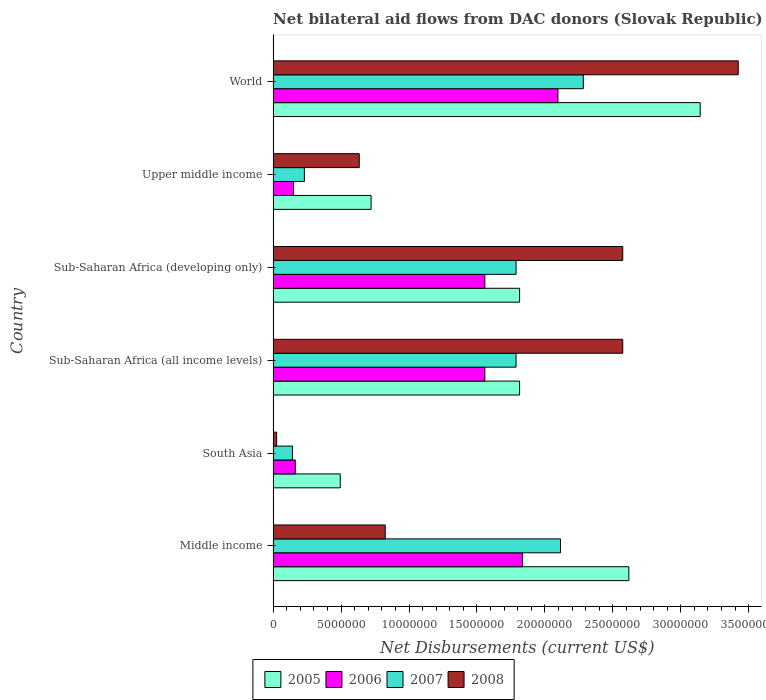How many different coloured bars are there?
Provide a succinct answer. 4. How many groups of bars are there?
Ensure brevity in your answer.  6. Are the number of bars per tick equal to the number of legend labels?
Your response must be concise. Yes. How many bars are there on the 5th tick from the top?
Offer a terse response. 4. How many bars are there on the 3rd tick from the bottom?
Keep it short and to the point. 4. What is the label of the 4th group of bars from the top?
Your answer should be compact. Sub-Saharan Africa (all income levels). In how many cases, is the number of bars for a given country not equal to the number of legend labels?
Offer a terse response. 0. What is the net bilateral aid flows in 2005 in World?
Ensure brevity in your answer.  3.14e+07. Across all countries, what is the maximum net bilateral aid flows in 2007?
Make the answer very short. 2.28e+07. Across all countries, what is the minimum net bilateral aid flows in 2008?
Offer a terse response. 2.60e+05. In which country was the net bilateral aid flows in 2006 minimum?
Provide a succinct answer. Upper middle income. What is the total net bilateral aid flows in 2007 in the graph?
Your response must be concise. 8.35e+07. What is the difference between the net bilateral aid flows in 2005 in Middle income and that in Sub-Saharan Africa (all income levels)?
Provide a succinct answer. 8.04e+06. What is the average net bilateral aid flows in 2008 per country?
Your response must be concise. 1.68e+07. What is the difference between the net bilateral aid flows in 2005 and net bilateral aid flows in 2008 in Sub-Saharan Africa (all income levels)?
Offer a very short reply. -7.59e+06. What is the ratio of the net bilateral aid flows in 2008 in South Asia to that in Sub-Saharan Africa (all income levels)?
Make the answer very short. 0.01. Is the net bilateral aid flows in 2007 in Middle income less than that in Upper middle income?
Your answer should be compact. No. Is the difference between the net bilateral aid flows in 2005 in Sub-Saharan Africa (developing only) and World greater than the difference between the net bilateral aid flows in 2008 in Sub-Saharan Africa (developing only) and World?
Your answer should be very brief. No. What is the difference between the highest and the second highest net bilateral aid flows in 2005?
Provide a succinct answer. 5.25e+06. What is the difference between the highest and the lowest net bilateral aid flows in 2007?
Provide a short and direct response. 2.14e+07. In how many countries, is the net bilateral aid flows in 2005 greater than the average net bilateral aid flows in 2005 taken over all countries?
Keep it short and to the point. 4. Is the sum of the net bilateral aid flows in 2007 in Upper middle income and World greater than the maximum net bilateral aid flows in 2005 across all countries?
Your answer should be very brief. No. What does the 4th bar from the bottom in Upper middle income represents?
Provide a succinct answer. 2008. Is it the case that in every country, the sum of the net bilateral aid flows in 2006 and net bilateral aid flows in 2005 is greater than the net bilateral aid flows in 2008?
Provide a short and direct response. Yes. Are all the bars in the graph horizontal?
Offer a terse response. Yes. What is the difference between two consecutive major ticks on the X-axis?
Your answer should be compact. 5.00e+06. Where does the legend appear in the graph?
Provide a succinct answer. Bottom center. How many legend labels are there?
Provide a short and direct response. 4. How are the legend labels stacked?
Offer a very short reply. Horizontal. What is the title of the graph?
Offer a very short reply. Net bilateral aid flows from DAC donors (Slovak Republic). Does "1991" appear as one of the legend labels in the graph?
Make the answer very short. No. What is the label or title of the X-axis?
Offer a terse response. Net Disbursements (current US$). What is the Net Disbursements (current US$) of 2005 in Middle income?
Give a very brief answer. 2.62e+07. What is the Net Disbursements (current US$) in 2006 in Middle income?
Provide a short and direct response. 1.84e+07. What is the Net Disbursements (current US$) in 2007 in Middle income?
Ensure brevity in your answer.  2.12e+07. What is the Net Disbursements (current US$) of 2008 in Middle income?
Make the answer very short. 8.25e+06. What is the Net Disbursements (current US$) in 2005 in South Asia?
Provide a succinct answer. 4.94e+06. What is the Net Disbursements (current US$) in 2006 in South Asia?
Your answer should be compact. 1.63e+06. What is the Net Disbursements (current US$) in 2007 in South Asia?
Provide a short and direct response. 1.42e+06. What is the Net Disbursements (current US$) in 2005 in Sub-Saharan Africa (all income levels)?
Your answer should be compact. 1.81e+07. What is the Net Disbursements (current US$) in 2006 in Sub-Saharan Africa (all income levels)?
Provide a succinct answer. 1.56e+07. What is the Net Disbursements (current US$) of 2007 in Sub-Saharan Africa (all income levels)?
Ensure brevity in your answer.  1.79e+07. What is the Net Disbursements (current US$) of 2008 in Sub-Saharan Africa (all income levels)?
Provide a short and direct response. 2.57e+07. What is the Net Disbursements (current US$) of 2005 in Sub-Saharan Africa (developing only)?
Your answer should be compact. 1.81e+07. What is the Net Disbursements (current US$) of 2006 in Sub-Saharan Africa (developing only)?
Offer a terse response. 1.56e+07. What is the Net Disbursements (current US$) of 2007 in Sub-Saharan Africa (developing only)?
Make the answer very short. 1.79e+07. What is the Net Disbursements (current US$) in 2008 in Sub-Saharan Africa (developing only)?
Keep it short and to the point. 2.57e+07. What is the Net Disbursements (current US$) of 2005 in Upper middle income?
Give a very brief answer. 7.21e+06. What is the Net Disbursements (current US$) in 2006 in Upper middle income?
Offer a terse response. 1.50e+06. What is the Net Disbursements (current US$) of 2007 in Upper middle income?
Your answer should be very brief. 2.30e+06. What is the Net Disbursements (current US$) in 2008 in Upper middle income?
Your answer should be very brief. 6.34e+06. What is the Net Disbursements (current US$) of 2005 in World?
Your answer should be compact. 3.14e+07. What is the Net Disbursements (current US$) in 2006 in World?
Make the answer very short. 2.10e+07. What is the Net Disbursements (current US$) of 2007 in World?
Your response must be concise. 2.28e+07. What is the Net Disbursements (current US$) in 2008 in World?
Provide a short and direct response. 3.42e+07. Across all countries, what is the maximum Net Disbursements (current US$) of 2005?
Your response must be concise. 3.14e+07. Across all countries, what is the maximum Net Disbursements (current US$) in 2006?
Offer a very short reply. 2.10e+07. Across all countries, what is the maximum Net Disbursements (current US$) of 2007?
Keep it short and to the point. 2.28e+07. Across all countries, what is the maximum Net Disbursements (current US$) in 2008?
Provide a succinct answer. 3.42e+07. Across all countries, what is the minimum Net Disbursements (current US$) of 2005?
Give a very brief answer. 4.94e+06. Across all countries, what is the minimum Net Disbursements (current US$) in 2006?
Your answer should be very brief. 1.50e+06. Across all countries, what is the minimum Net Disbursements (current US$) in 2007?
Your answer should be very brief. 1.42e+06. Across all countries, what is the minimum Net Disbursements (current US$) of 2008?
Make the answer very short. 2.60e+05. What is the total Net Disbursements (current US$) of 2005 in the graph?
Make the answer very short. 1.06e+08. What is the total Net Disbursements (current US$) of 2006 in the graph?
Make the answer very short. 7.36e+07. What is the total Net Disbursements (current US$) in 2007 in the graph?
Offer a very short reply. 8.35e+07. What is the total Net Disbursements (current US$) in 2008 in the graph?
Your answer should be very brief. 1.01e+08. What is the difference between the Net Disbursements (current US$) in 2005 in Middle income and that in South Asia?
Give a very brief answer. 2.12e+07. What is the difference between the Net Disbursements (current US$) in 2006 in Middle income and that in South Asia?
Offer a very short reply. 1.67e+07. What is the difference between the Net Disbursements (current US$) of 2007 in Middle income and that in South Asia?
Keep it short and to the point. 1.97e+07. What is the difference between the Net Disbursements (current US$) in 2008 in Middle income and that in South Asia?
Offer a very short reply. 7.99e+06. What is the difference between the Net Disbursements (current US$) in 2005 in Middle income and that in Sub-Saharan Africa (all income levels)?
Provide a short and direct response. 8.04e+06. What is the difference between the Net Disbursements (current US$) in 2006 in Middle income and that in Sub-Saharan Africa (all income levels)?
Provide a succinct answer. 2.77e+06. What is the difference between the Net Disbursements (current US$) of 2007 in Middle income and that in Sub-Saharan Africa (all income levels)?
Provide a succinct answer. 3.27e+06. What is the difference between the Net Disbursements (current US$) in 2008 in Middle income and that in Sub-Saharan Africa (all income levels)?
Give a very brief answer. -1.75e+07. What is the difference between the Net Disbursements (current US$) in 2005 in Middle income and that in Sub-Saharan Africa (developing only)?
Make the answer very short. 8.04e+06. What is the difference between the Net Disbursements (current US$) of 2006 in Middle income and that in Sub-Saharan Africa (developing only)?
Give a very brief answer. 2.77e+06. What is the difference between the Net Disbursements (current US$) in 2007 in Middle income and that in Sub-Saharan Africa (developing only)?
Your answer should be very brief. 3.27e+06. What is the difference between the Net Disbursements (current US$) of 2008 in Middle income and that in Sub-Saharan Africa (developing only)?
Provide a short and direct response. -1.75e+07. What is the difference between the Net Disbursements (current US$) in 2005 in Middle income and that in Upper middle income?
Make the answer very short. 1.90e+07. What is the difference between the Net Disbursements (current US$) in 2006 in Middle income and that in Upper middle income?
Offer a terse response. 1.68e+07. What is the difference between the Net Disbursements (current US$) in 2007 in Middle income and that in Upper middle income?
Offer a very short reply. 1.88e+07. What is the difference between the Net Disbursements (current US$) in 2008 in Middle income and that in Upper middle income?
Provide a succinct answer. 1.91e+06. What is the difference between the Net Disbursements (current US$) in 2005 in Middle income and that in World?
Give a very brief answer. -5.25e+06. What is the difference between the Net Disbursements (current US$) in 2006 in Middle income and that in World?
Offer a terse response. -2.61e+06. What is the difference between the Net Disbursements (current US$) of 2007 in Middle income and that in World?
Your response must be concise. -1.68e+06. What is the difference between the Net Disbursements (current US$) in 2008 in Middle income and that in World?
Your answer should be very brief. -2.60e+07. What is the difference between the Net Disbursements (current US$) in 2005 in South Asia and that in Sub-Saharan Africa (all income levels)?
Your answer should be compact. -1.32e+07. What is the difference between the Net Disbursements (current US$) of 2006 in South Asia and that in Sub-Saharan Africa (all income levels)?
Your response must be concise. -1.40e+07. What is the difference between the Net Disbursements (current US$) of 2007 in South Asia and that in Sub-Saharan Africa (all income levels)?
Your answer should be compact. -1.65e+07. What is the difference between the Net Disbursements (current US$) in 2008 in South Asia and that in Sub-Saharan Africa (all income levels)?
Your response must be concise. -2.55e+07. What is the difference between the Net Disbursements (current US$) in 2005 in South Asia and that in Sub-Saharan Africa (developing only)?
Your response must be concise. -1.32e+07. What is the difference between the Net Disbursements (current US$) in 2006 in South Asia and that in Sub-Saharan Africa (developing only)?
Your answer should be compact. -1.40e+07. What is the difference between the Net Disbursements (current US$) in 2007 in South Asia and that in Sub-Saharan Africa (developing only)?
Ensure brevity in your answer.  -1.65e+07. What is the difference between the Net Disbursements (current US$) of 2008 in South Asia and that in Sub-Saharan Africa (developing only)?
Your answer should be very brief. -2.55e+07. What is the difference between the Net Disbursements (current US$) of 2005 in South Asia and that in Upper middle income?
Give a very brief answer. -2.27e+06. What is the difference between the Net Disbursements (current US$) in 2006 in South Asia and that in Upper middle income?
Offer a terse response. 1.30e+05. What is the difference between the Net Disbursements (current US$) in 2007 in South Asia and that in Upper middle income?
Offer a terse response. -8.80e+05. What is the difference between the Net Disbursements (current US$) of 2008 in South Asia and that in Upper middle income?
Your answer should be compact. -6.08e+06. What is the difference between the Net Disbursements (current US$) of 2005 in South Asia and that in World?
Offer a very short reply. -2.65e+07. What is the difference between the Net Disbursements (current US$) in 2006 in South Asia and that in World?
Give a very brief answer. -1.93e+07. What is the difference between the Net Disbursements (current US$) of 2007 in South Asia and that in World?
Your answer should be very brief. -2.14e+07. What is the difference between the Net Disbursements (current US$) in 2008 in South Asia and that in World?
Provide a short and direct response. -3.40e+07. What is the difference between the Net Disbursements (current US$) of 2006 in Sub-Saharan Africa (all income levels) and that in Sub-Saharan Africa (developing only)?
Your answer should be very brief. 0. What is the difference between the Net Disbursements (current US$) in 2007 in Sub-Saharan Africa (all income levels) and that in Sub-Saharan Africa (developing only)?
Provide a short and direct response. 0. What is the difference between the Net Disbursements (current US$) in 2005 in Sub-Saharan Africa (all income levels) and that in Upper middle income?
Make the answer very short. 1.09e+07. What is the difference between the Net Disbursements (current US$) of 2006 in Sub-Saharan Africa (all income levels) and that in Upper middle income?
Your response must be concise. 1.41e+07. What is the difference between the Net Disbursements (current US$) in 2007 in Sub-Saharan Africa (all income levels) and that in Upper middle income?
Your response must be concise. 1.56e+07. What is the difference between the Net Disbursements (current US$) in 2008 in Sub-Saharan Africa (all income levels) and that in Upper middle income?
Ensure brevity in your answer.  1.94e+07. What is the difference between the Net Disbursements (current US$) of 2005 in Sub-Saharan Africa (all income levels) and that in World?
Your answer should be compact. -1.33e+07. What is the difference between the Net Disbursements (current US$) in 2006 in Sub-Saharan Africa (all income levels) and that in World?
Offer a terse response. -5.38e+06. What is the difference between the Net Disbursements (current US$) of 2007 in Sub-Saharan Africa (all income levels) and that in World?
Make the answer very short. -4.95e+06. What is the difference between the Net Disbursements (current US$) in 2008 in Sub-Saharan Africa (all income levels) and that in World?
Offer a terse response. -8.50e+06. What is the difference between the Net Disbursements (current US$) of 2005 in Sub-Saharan Africa (developing only) and that in Upper middle income?
Your answer should be very brief. 1.09e+07. What is the difference between the Net Disbursements (current US$) in 2006 in Sub-Saharan Africa (developing only) and that in Upper middle income?
Make the answer very short. 1.41e+07. What is the difference between the Net Disbursements (current US$) of 2007 in Sub-Saharan Africa (developing only) and that in Upper middle income?
Give a very brief answer. 1.56e+07. What is the difference between the Net Disbursements (current US$) in 2008 in Sub-Saharan Africa (developing only) and that in Upper middle income?
Keep it short and to the point. 1.94e+07. What is the difference between the Net Disbursements (current US$) of 2005 in Sub-Saharan Africa (developing only) and that in World?
Your response must be concise. -1.33e+07. What is the difference between the Net Disbursements (current US$) of 2006 in Sub-Saharan Africa (developing only) and that in World?
Provide a succinct answer. -5.38e+06. What is the difference between the Net Disbursements (current US$) of 2007 in Sub-Saharan Africa (developing only) and that in World?
Keep it short and to the point. -4.95e+06. What is the difference between the Net Disbursements (current US$) of 2008 in Sub-Saharan Africa (developing only) and that in World?
Offer a very short reply. -8.50e+06. What is the difference between the Net Disbursements (current US$) in 2005 in Upper middle income and that in World?
Make the answer very short. -2.42e+07. What is the difference between the Net Disbursements (current US$) of 2006 in Upper middle income and that in World?
Your answer should be very brief. -1.95e+07. What is the difference between the Net Disbursements (current US$) in 2007 in Upper middle income and that in World?
Ensure brevity in your answer.  -2.05e+07. What is the difference between the Net Disbursements (current US$) of 2008 in Upper middle income and that in World?
Keep it short and to the point. -2.79e+07. What is the difference between the Net Disbursements (current US$) of 2005 in Middle income and the Net Disbursements (current US$) of 2006 in South Asia?
Provide a short and direct response. 2.46e+07. What is the difference between the Net Disbursements (current US$) in 2005 in Middle income and the Net Disbursements (current US$) in 2007 in South Asia?
Ensure brevity in your answer.  2.48e+07. What is the difference between the Net Disbursements (current US$) in 2005 in Middle income and the Net Disbursements (current US$) in 2008 in South Asia?
Make the answer very short. 2.59e+07. What is the difference between the Net Disbursements (current US$) of 2006 in Middle income and the Net Disbursements (current US$) of 2007 in South Asia?
Offer a very short reply. 1.69e+07. What is the difference between the Net Disbursements (current US$) in 2006 in Middle income and the Net Disbursements (current US$) in 2008 in South Asia?
Your answer should be compact. 1.81e+07. What is the difference between the Net Disbursements (current US$) in 2007 in Middle income and the Net Disbursements (current US$) in 2008 in South Asia?
Offer a very short reply. 2.09e+07. What is the difference between the Net Disbursements (current US$) in 2005 in Middle income and the Net Disbursements (current US$) in 2006 in Sub-Saharan Africa (all income levels)?
Provide a short and direct response. 1.06e+07. What is the difference between the Net Disbursements (current US$) in 2005 in Middle income and the Net Disbursements (current US$) in 2007 in Sub-Saharan Africa (all income levels)?
Keep it short and to the point. 8.30e+06. What is the difference between the Net Disbursements (current US$) in 2006 in Middle income and the Net Disbursements (current US$) in 2008 in Sub-Saharan Africa (all income levels)?
Your answer should be compact. -7.38e+06. What is the difference between the Net Disbursements (current US$) in 2007 in Middle income and the Net Disbursements (current US$) in 2008 in Sub-Saharan Africa (all income levels)?
Ensure brevity in your answer.  -4.58e+06. What is the difference between the Net Disbursements (current US$) in 2005 in Middle income and the Net Disbursements (current US$) in 2006 in Sub-Saharan Africa (developing only)?
Provide a succinct answer. 1.06e+07. What is the difference between the Net Disbursements (current US$) in 2005 in Middle income and the Net Disbursements (current US$) in 2007 in Sub-Saharan Africa (developing only)?
Provide a short and direct response. 8.30e+06. What is the difference between the Net Disbursements (current US$) in 2005 in Middle income and the Net Disbursements (current US$) in 2008 in Sub-Saharan Africa (developing only)?
Offer a terse response. 4.50e+05. What is the difference between the Net Disbursements (current US$) in 2006 in Middle income and the Net Disbursements (current US$) in 2008 in Sub-Saharan Africa (developing only)?
Keep it short and to the point. -7.38e+06. What is the difference between the Net Disbursements (current US$) of 2007 in Middle income and the Net Disbursements (current US$) of 2008 in Sub-Saharan Africa (developing only)?
Offer a very short reply. -4.58e+06. What is the difference between the Net Disbursements (current US$) in 2005 in Middle income and the Net Disbursements (current US$) in 2006 in Upper middle income?
Ensure brevity in your answer.  2.47e+07. What is the difference between the Net Disbursements (current US$) of 2005 in Middle income and the Net Disbursements (current US$) of 2007 in Upper middle income?
Your answer should be compact. 2.39e+07. What is the difference between the Net Disbursements (current US$) of 2005 in Middle income and the Net Disbursements (current US$) of 2008 in Upper middle income?
Offer a terse response. 1.98e+07. What is the difference between the Net Disbursements (current US$) of 2006 in Middle income and the Net Disbursements (current US$) of 2007 in Upper middle income?
Make the answer very short. 1.60e+07. What is the difference between the Net Disbursements (current US$) of 2006 in Middle income and the Net Disbursements (current US$) of 2008 in Upper middle income?
Keep it short and to the point. 1.20e+07. What is the difference between the Net Disbursements (current US$) in 2007 in Middle income and the Net Disbursements (current US$) in 2008 in Upper middle income?
Keep it short and to the point. 1.48e+07. What is the difference between the Net Disbursements (current US$) in 2005 in Middle income and the Net Disbursements (current US$) in 2006 in World?
Your answer should be very brief. 5.22e+06. What is the difference between the Net Disbursements (current US$) in 2005 in Middle income and the Net Disbursements (current US$) in 2007 in World?
Provide a short and direct response. 3.35e+06. What is the difference between the Net Disbursements (current US$) in 2005 in Middle income and the Net Disbursements (current US$) in 2008 in World?
Make the answer very short. -8.05e+06. What is the difference between the Net Disbursements (current US$) in 2006 in Middle income and the Net Disbursements (current US$) in 2007 in World?
Offer a very short reply. -4.48e+06. What is the difference between the Net Disbursements (current US$) of 2006 in Middle income and the Net Disbursements (current US$) of 2008 in World?
Your response must be concise. -1.59e+07. What is the difference between the Net Disbursements (current US$) in 2007 in Middle income and the Net Disbursements (current US$) in 2008 in World?
Give a very brief answer. -1.31e+07. What is the difference between the Net Disbursements (current US$) in 2005 in South Asia and the Net Disbursements (current US$) in 2006 in Sub-Saharan Africa (all income levels)?
Your answer should be compact. -1.06e+07. What is the difference between the Net Disbursements (current US$) in 2005 in South Asia and the Net Disbursements (current US$) in 2007 in Sub-Saharan Africa (all income levels)?
Offer a terse response. -1.29e+07. What is the difference between the Net Disbursements (current US$) in 2005 in South Asia and the Net Disbursements (current US$) in 2008 in Sub-Saharan Africa (all income levels)?
Your answer should be very brief. -2.08e+07. What is the difference between the Net Disbursements (current US$) of 2006 in South Asia and the Net Disbursements (current US$) of 2007 in Sub-Saharan Africa (all income levels)?
Make the answer very short. -1.62e+07. What is the difference between the Net Disbursements (current US$) of 2006 in South Asia and the Net Disbursements (current US$) of 2008 in Sub-Saharan Africa (all income levels)?
Ensure brevity in your answer.  -2.41e+07. What is the difference between the Net Disbursements (current US$) of 2007 in South Asia and the Net Disbursements (current US$) of 2008 in Sub-Saharan Africa (all income levels)?
Provide a succinct answer. -2.43e+07. What is the difference between the Net Disbursements (current US$) in 2005 in South Asia and the Net Disbursements (current US$) in 2006 in Sub-Saharan Africa (developing only)?
Ensure brevity in your answer.  -1.06e+07. What is the difference between the Net Disbursements (current US$) of 2005 in South Asia and the Net Disbursements (current US$) of 2007 in Sub-Saharan Africa (developing only)?
Your answer should be compact. -1.29e+07. What is the difference between the Net Disbursements (current US$) in 2005 in South Asia and the Net Disbursements (current US$) in 2008 in Sub-Saharan Africa (developing only)?
Your answer should be compact. -2.08e+07. What is the difference between the Net Disbursements (current US$) in 2006 in South Asia and the Net Disbursements (current US$) in 2007 in Sub-Saharan Africa (developing only)?
Provide a short and direct response. -1.62e+07. What is the difference between the Net Disbursements (current US$) of 2006 in South Asia and the Net Disbursements (current US$) of 2008 in Sub-Saharan Africa (developing only)?
Ensure brevity in your answer.  -2.41e+07. What is the difference between the Net Disbursements (current US$) of 2007 in South Asia and the Net Disbursements (current US$) of 2008 in Sub-Saharan Africa (developing only)?
Your answer should be compact. -2.43e+07. What is the difference between the Net Disbursements (current US$) of 2005 in South Asia and the Net Disbursements (current US$) of 2006 in Upper middle income?
Your answer should be very brief. 3.44e+06. What is the difference between the Net Disbursements (current US$) in 2005 in South Asia and the Net Disbursements (current US$) in 2007 in Upper middle income?
Give a very brief answer. 2.64e+06. What is the difference between the Net Disbursements (current US$) of 2005 in South Asia and the Net Disbursements (current US$) of 2008 in Upper middle income?
Your answer should be compact. -1.40e+06. What is the difference between the Net Disbursements (current US$) of 2006 in South Asia and the Net Disbursements (current US$) of 2007 in Upper middle income?
Your answer should be compact. -6.70e+05. What is the difference between the Net Disbursements (current US$) of 2006 in South Asia and the Net Disbursements (current US$) of 2008 in Upper middle income?
Offer a terse response. -4.71e+06. What is the difference between the Net Disbursements (current US$) in 2007 in South Asia and the Net Disbursements (current US$) in 2008 in Upper middle income?
Give a very brief answer. -4.92e+06. What is the difference between the Net Disbursements (current US$) in 2005 in South Asia and the Net Disbursements (current US$) in 2006 in World?
Your answer should be compact. -1.60e+07. What is the difference between the Net Disbursements (current US$) in 2005 in South Asia and the Net Disbursements (current US$) in 2007 in World?
Ensure brevity in your answer.  -1.79e+07. What is the difference between the Net Disbursements (current US$) of 2005 in South Asia and the Net Disbursements (current US$) of 2008 in World?
Keep it short and to the point. -2.93e+07. What is the difference between the Net Disbursements (current US$) in 2006 in South Asia and the Net Disbursements (current US$) in 2007 in World?
Ensure brevity in your answer.  -2.12e+07. What is the difference between the Net Disbursements (current US$) in 2006 in South Asia and the Net Disbursements (current US$) in 2008 in World?
Ensure brevity in your answer.  -3.26e+07. What is the difference between the Net Disbursements (current US$) of 2007 in South Asia and the Net Disbursements (current US$) of 2008 in World?
Give a very brief answer. -3.28e+07. What is the difference between the Net Disbursements (current US$) of 2005 in Sub-Saharan Africa (all income levels) and the Net Disbursements (current US$) of 2006 in Sub-Saharan Africa (developing only)?
Provide a succinct answer. 2.56e+06. What is the difference between the Net Disbursements (current US$) in 2005 in Sub-Saharan Africa (all income levels) and the Net Disbursements (current US$) in 2007 in Sub-Saharan Africa (developing only)?
Your answer should be compact. 2.60e+05. What is the difference between the Net Disbursements (current US$) in 2005 in Sub-Saharan Africa (all income levels) and the Net Disbursements (current US$) in 2008 in Sub-Saharan Africa (developing only)?
Keep it short and to the point. -7.59e+06. What is the difference between the Net Disbursements (current US$) of 2006 in Sub-Saharan Africa (all income levels) and the Net Disbursements (current US$) of 2007 in Sub-Saharan Africa (developing only)?
Your answer should be compact. -2.30e+06. What is the difference between the Net Disbursements (current US$) of 2006 in Sub-Saharan Africa (all income levels) and the Net Disbursements (current US$) of 2008 in Sub-Saharan Africa (developing only)?
Your answer should be very brief. -1.02e+07. What is the difference between the Net Disbursements (current US$) in 2007 in Sub-Saharan Africa (all income levels) and the Net Disbursements (current US$) in 2008 in Sub-Saharan Africa (developing only)?
Your response must be concise. -7.85e+06. What is the difference between the Net Disbursements (current US$) of 2005 in Sub-Saharan Africa (all income levels) and the Net Disbursements (current US$) of 2006 in Upper middle income?
Offer a terse response. 1.66e+07. What is the difference between the Net Disbursements (current US$) in 2005 in Sub-Saharan Africa (all income levels) and the Net Disbursements (current US$) in 2007 in Upper middle income?
Your response must be concise. 1.58e+07. What is the difference between the Net Disbursements (current US$) in 2005 in Sub-Saharan Africa (all income levels) and the Net Disbursements (current US$) in 2008 in Upper middle income?
Your answer should be compact. 1.18e+07. What is the difference between the Net Disbursements (current US$) in 2006 in Sub-Saharan Africa (all income levels) and the Net Disbursements (current US$) in 2007 in Upper middle income?
Your answer should be compact. 1.33e+07. What is the difference between the Net Disbursements (current US$) of 2006 in Sub-Saharan Africa (all income levels) and the Net Disbursements (current US$) of 2008 in Upper middle income?
Offer a terse response. 9.24e+06. What is the difference between the Net Disbursements (current US$) in 2007 in Sub-Saharan Africa (all income levels) and the Net Disbursements (current US$) in 2008 in Upper middle income?
Give a very brief answer. 1.15e+07. What is the difference between the Net Disbursements (current US$) of 2005 in Sub-Saharan Africa (all income levels) and the Net Disbursements (current US$) of 2006 in World?
Offer a terse response. -2.82e+06. What is the difference between the Net Disbursements (current US$) of 2005 in Sub-Saharan Africa (all income levels) and the Net Disbursements (current US$) of 2007 in World?
Provide a short and direct response. -4.69e+06. What is the difference between the Net Disbursements (current US$) of 2005 in Sub-Saharan Africa (all income levels) and the Net Disbursements (current US$) of 2008 in World?
Give a very brief answer. -1.61e+07. What is the difference between the Net Disbursements (current US$) in 2006 in Sub-Saharan Africa (all income levels) and the Net Disbursements (current US$) in 2007 in World?
Your answer should be very brief. -7.25e+06. What is the difference between the Net Disbursements (current US$) in 2006 in Sub-Saharan Africa (all income levels) and the Net Disbursements (current US$) in 2008 in World?
Make the answer very short. -1.86e+07. What is the difference between the Net Disbursements (current US$) of 2007 in Sub-Saharan Africa (all income levels) and the Net Disbursements (current US$) of 2008 in World?
Your response must be concise. -1.64e+07. What is the difference between the Net Disbursements (current US$) in 2005 in Sub-Saharan Africa (developing only) and the Net Disbursements (current US$) in 2006 in Upper middle income?
Provide a succinct answer. 1.66e+07. What is the difference between the Net Disbursements (current US$) in 2005 in Sub-Saharan Africa (developing only) and the Net Disbursements (current US$) in 2007 in Upper middle income?
Ensure brevity in your answer.  1.58e+07. What is the difference between the Net Disbursements (current US$) in 2005 in Sub-Saharan Africa (developing only) and the Net Disbursements (current US$) in 2008 in Upper middle income?
Provide a short and direct response. 1.18e+07. What is the difference between the Net Disbursements (current US$) of 2006 in Sub-Saharan Africa (developing only) and the Net Disbursements (current US$) of 2007 in Upper middle income?
Offer a very short reply. 1.33e+07. What is the difference between the Net Disbursements (current US$) of 2006 in Sub-Saharan Africa (developing only) and the Net Disbursements (current US$) of 2008 in Upper middle income?
Make the answer very short. 9.24e+06. What is the difference between the Net Disbursements (current US$) in 2007 in Sub-Saharan Africa (developing only) and the Net Disbursements (current US$) in 2008 in Upper middle income?
Your answer should be compact. 1.15e+07. What is the difference between the Net Disbursements (current US$) in 2005 in Sub-Saharan Africa (developing only) and the Net Disbursements (current US$) in 2006 in World?
Your answer should be compact. -2.82e+06. What is the difference between the Net Disbursements (current US$) in 2005 in Sub-Saharan Africa (developing only) and the Net Disbursements (current US$) in 2007 in World?
Your response must be concise. -4.69e+06. What is the difference between the Net Disbursements (current US$) of 2005 in Sub-Saharan Africa (developing only) and the Net Disbursements (current US$) of 2008 in World?
Your answer should be very brief. -1.61e+07. What is the difference between the Net Disbursements (current US$) of 2006 in Sub-Saharan Africa (developing only) and the Net Disbursements (current US$) of 2007 in World?
Your response must be concise. -7.25e+06. What is the difference between the Net Disbursements (current US$) in 2006 in Sub-Saharan Africa (developing only) and the Net Disbursements (current US$) in 2008 in World?
Offer a terse response. -1.86e+07. What is the difference between the Net Disbursements (current US$) in 2007 in Sub-Saharan Africa (developing only) and the Net Disbursements (current US$) in 2008 in World?
Your answer should be very brief. -1.64e+07. What is the difference between the Net Disbursements (current US$) in 2005 in Upper middle income and the Net Disbursements (current US$) in 2006 in World?
Your response must be concise. -1.38e+07. What is the difference between the Net Disbursements (current US$) of 2005 in Upper middle income and the Net Disbursements (current US$) of 2007 in World?
Offer a terse response. -1.56e+07. What is the difference between the Net Disbursements (current US$) of 2005 in Upper middle income and the Net Disbursements (current US$) of 2008 in World?
Provide a short and direct response. -2.70e+07. What is the difference between the Net Disbursements (current US$) of 2006 in Upper middle income and the Net Disbursements (current US$) of 2007 in World?
Keep it short and to the point. -2.13e+07. What is the difference between the Net Disbursements (current US$) in 2006 in Upper middle income and the Net Disbursements (current US$) in 2008 in World?
Give a very brief answer. -3.27e+07. What is the difference between the Net Disbursements (current US$) in 2007 in Upper middle income and the Net Disbursements (current US$) in 2008 in World?
Your answer should be very brief. -3.19e+07. What is the average Net Disbursements (current US$) of 2005 per country?
Ensure brevity in your answer.  1.77e+07. What is the average Net Disbursements (current US$) of 2006 per country?
Offer a terse response. 1.23e+07. What is the average Net Disbursements (current US$) in 2007 per country?
Keep it short and to the point. 1.39e+07. What is the average Net Disbursements (current US$) in 2008 per country?
Your answer should be very brief. 1.68e+07. What is the difference between the Net Disbursements (current US$) in 2005 and Net Disbursements (current US$) in 2006 in Middle income?
Your answer should be compact. 7.83e+06. What is the difference between the Net Disbursements (current US$) in 2005 and Net Disbursements (current US$) in 2007 in Middle income?
Offer a very short reply. 5.03e+06. What is the difference between the Net Disbursements (current US$) in 2005 and Net Disbursements (current US$) in 2008 in Middle income?
Provide a short and direct response. 1.79e+07. What is the difference between the Net Disbursements (current US$) of 2006 and Net Disbursements (current US$) of 2007 in Middle income?
Offer a terse response. -2.80e+06. What is the difference between the Net Disbursements (current US$) in 2006 and Net Disbursements (current US$) in 2008 in Middle income?
Provide a short and direct response. 1.01e+07. What is the difference between the Net Disbursements (current US$) of 2007 and Net Disbursements (current US$) of 2008 in Middle income?
Provide a short and direct response. 1.29e+07. What is the difference between the Net Disbursements (current US$) in 2005 and Net Disbursements (current US$) in 2006 in South Asia?
Give a very brief answer. 3.31e+06. What is the difference between the Net Disbursements (current US$) of 2005 and Net Disbursements (current US$) of 2007 in South Asia?
Provide a succinct answer. 3.52e+06. What is the difference between the Net Disbursements (current US$) in 2005 and Net Disbursements (current US$) in 2008 in South Asia?
Your answer should be compact. 4.68e+06. What is the difference between the Net Disbursements (current US$) in 2006 and Net Disbursements (current US$) in 2007 in South Asia?
Offer a terse response. 2.10e+05. What is the difference between the Net Disbursements (current US$) of 2006 and Net Disbursements (current US$) of 2008 in South Asia?
Provide a succinct answer. 1.37e+06. What is the difference between the Net Disbursements (current US$) in 2007 and Net Disbursements (current US$) in 2008 in South Asia?
Offer a very short reply. 1.16e+06. What is the difference between the Net Disbursements (current US$) of 2005 and Net Disbursements (current US$) of 2006 in Sub-Saharan Africa (all income levels)?
Your answer should be very brief. 2.56e+06. What is the difference between the Net Disbursements (current US$) of 2005 and Net Disbursements (current US$) of 2008 in Sub-Saharan Africa (all income levels)?
Offer a terse response. -7.59e+06. What is the difference between the Net Disbursements (current US$) of 2006 and Net Disbursements (current US$) of 2007 in Sub-Saharan Africa (all income levels)?
Give a very brief answer. -2.30e+06. What is the difference between the Net Disbursements (current US$) in 2006 and Net Disbursements (current US$) in 2008 in Sub-Saharan Africa (all income levels)?
Provide a short and direct response. -1.02e+07. What is the difference between the Net Disbursements (current US$) in 2007 and Net Disbursements (current US$) in 2008 in Sub-Saharan Africa (all income levels)?
Offer a very short reply. -7.85e+06. What is the difference between the Net Disbursements (current US$) in 2005 and Net Disbursements (current US$) in 2006 in Sub-Saharan Africa (developing only)?
Offer a very short reply. 2.56e+06. What is the difference between the Net Disbursements (current US$) in 2005 and Net Disbursements (current US$) in 2007 in Sub-Saharan Africa (developing only)?
Provide a short and direct response. 2.60e+05. What is the difference between the Net Disbursements (current US$) in 2005 and Net Disbursements (current US$) in 2008 in Sub-Saharan Africa (developing only)?
Your response must be concise. -7.59e+06. What is the difference between the Net Disbursements (current US$) of 2006 and Net Disbursements (current US$) of 2007 in Sub-Saharan Africa (developing only)?
Give a very brief answer. -2.30e+06. What is the difference between the Net Disbursements (current US$) in 2006 and Net Disbursements (current US$) in 2008 in Sub-Saharan Africa (developing only)?
Offer a terse response. -1.02e+07. What is the difference between the Net Disbursements (current US$) of 2007 and Net Disbursements (current US$) of 2008 in Sub-Saharan Africa (developing only)?
Make the answer very short. -7.85e+06. What is the difference between the Net Disbursements (current US$) of 2005 and Net Disbursements (current US$) of 2006 in Upper middle income?
Ensure brevity in your answer.  5.71e+06. What is the difference between the Net Disbursements (current US$) of 2005 and Net Disbursements (current US$) of 2007 in Upper middle income?
Make the answer very short. 4.91e+06. What is the difference between the Net Disbursements (current US$) of 2005 and Net Disbursements (current US$) of 2008 in Upper middle income?
Your response must be concise. 8.70e+05. What is the difference between the Net Disbursements (current US$) in 2006 and Net Disbursements (current US$) in 2007 in Upper middle income?
Keep it short and to the point. -8.00e+05. What is the difference between the Net Disbursements (current US$) in 2006 and Net Disbursements (current US$) in 2008 in Upper middle income?
Your response must be concise. -4.84e+06. What is the difference between the Net Disbursements (current US$) of 2007 and Net Disbursements (current US$) of 2008 in Upper middle income?
Offer a terse response. -4.04e+06. What is the difference between the Net Disbursements (current US$) of 2005 and Net Disbursements (current US$) of 2006 in World?
Provide a succinct answer. 1.05e+07. What is the difference between the Net Disbursements (current US$) of 2005 and Net Disbursements (current US$) of 2007 in World?
Your answer should be very brief. 8.60e+06. What is the difference between the Net Disbursements (current US$) of 2005 and Net Disbursements (current US$) of 2008 in World?
Keep it short and to the point. -2.80e+06. What is the difference between the Net Disbursements (current US$) in 2006 and Net Disbursements (current US$) in 2007 in World?
Provide a short and direct response. -1.87e+06. What is the difference between the Net Disbursements (current US$) in 2006 and Net Disbursements (current US$) in 2008 in World?
Make the answer very short. -1.33e+07. What is the difference between the Net Disbursements (current US$) of 2007 and Net Disbursements (current US$) of 2008 in World?
Ensure brevity in your answer.  -1.14e+07. What is the ratio of the Net Disbursements (current US$) of 2005 in Middle income to that in South Asia?
Give a very brief answer. 5.3. What is the ratio of the Net Disbursements (current US$) of 2006 in Middle income to that in South Asia?
Your answer should be very brief. 11.26. What is the ratio of the Net Disbursements (current US$) in 2007 in Middle income to that in South Asia?
Your answer should be compact. 14.89. What is the ratio of the Net Disbursements (current US$) of 2008 in Middle income to that in South Asia?
Provide a short and direct response. 31.73. What is the ratio of the Net Disbursements (current US$) of 2005 in Middle income to that in Sub-Saharan Africa (all income levels)?
Give a very brief answer. 1.44. What is the ratio of the Net Disbursements (current US$) in 2006 in Middle income to that in Sub-Saharan Africa (all income levels)?
Provide a succinct answer. 1.18. What is the ratio of the Net Disbursements (current US$) in 2007 in Middle income to that in Sub-Saharan Africa (all income levels)?
Provide a short and direct response. 1.18. What is the ratio of the Net Disbursements (current US$) of 2008 in Middle income to that in Sub-Saharan Africa (all income levels)?
Provide a short and direct response. 0.32. What is the ratio of the Net Disbursements (current US$) in 2005 in Middle income to that in Sub-Saharan Africa (developing only)?
Provide a short and direct response. 1.44. What is the ratio of the Net Disbursements (current US$) of 2006 in Middle income to that in Sub-Saharan Africa (developing only)?
Offer a terse response. 1.18. What is the ratio of the Net Disbursements (current US$) in 2007 in Middle income to that in Sub-Saharan Africa (developing only)?
Your answer should be compact. 1.18. What is the ratio of the Net Disbursements (current US$) in 2008 in Middle income to that in Sub-Saharan Africa (developing only)?
Make the answer very short. 0.32. What is the ratio of the Net Disbursements (current US$) of 2005 in Middle income to that in Upper middle income?
Offer a very short reply. 3.63. What is the ratio of the Net Disbursements (current US$) of 2006 in Middle income to that in Upper middle income?
Your response must be concise. 12.23. What is the ratio of the Net Disbursements (current US$) in 2007 in Middle income to that in Upper middle income?
Offer a very short reply. 9.2. What is the ratio of the Net Disbursements (current US$) in 2008 in Middle income to that in Upper middle income?
Give a very brief answer. 1.3. What is the ratio of the Net Disbursements (current US$) in 2005 in Middle income to that in World?
Offer a terse response. 0.83. What is the ratio of the Net Disbursements (current US$) of 2006 in Middle income to that in World?
Provide a succinct answer. 0.88. What is the ratio of the Net Disbursements (current US$) in 2007 in Middle income to that in World?
Provide a short and direct response. 0.93. What is the ratio of the Net Disbursements (current US$) in 2008 in Middle income to that in World?
Ensure brevity in your answer.  0.24. What is the ratio of the Net Disbursements (current US$) in 2005 in South Asia to that in Sub-Saharan Africa (all income levels)?
Provide a short and direct response. 0.27. What is the ratio of the Net Disbursements (current US$) of 2006 in South Asia to that in Sub-Saharan Africa (all income levels)?
Keep it short and to the point. 0.1. What is the ratio of the Net Disbursements (current US$) in 2007 in South Asia to that in Sub-Saharan Africa (all income levels)?
Offer a very short reply. 0.08. What is the ratio of the Net Disbursements (current US$) of 2008 in South Asia to that in Sub-Saharan Africa (all income levels)?
Give a very brief answer. 0.01. What is the ratio of the Net Disbursements (current US$) in 2005 in South Asia to that in Sub-Saharan Africa (developing only)?
Keep it short and to the point. 0.27. What is the ratio of the Net Disbursements (current US$) of 2006 in South Asia to that in Sub-Saharan Africa (developing only)?
Keep it short and to the point. 0.1. What is the ratio of the Net Disbursements (current US$) in 2007 in South Asia to that in Sub-Saharan Africa (developing only)?
Your response must be concise. 0.08. What is the ratio of the Net Disbursements (current US$) of 2008 in South Asia to that in Sub-Saharan Africa (developing only)?
Provide a succinct answer. 0.01. What is the ratio of the Net Disbursements (current US$) in 2005 in South Asia to that in Upper middle income?
Provide a short and direct response. 0.69. What is the ratio of the Net Disbursements (current US$) of 2006 in South Asia to that in Upper middle income?
Ensure brevity in your answer.  1.09. What is the ratio of the Net Disbursements (current US$) of 2007 in South Asia to that in Upper middle income?
Offer a very short reply. 0.62. What is the ratio of the Net Disbursements (current US$) in 2008 in South Asia to that in Upper middle income?
Offer a terse response. 0.04. What is the ratio of the Net Disbursements (current US$) of 2005 in South Asia to that in World?
Your answer should be very brief. 0.16. What is the ratio of the Net Disbursements (current US$) in 2006 in South Asia to that in World?
Your answer should be compact. 0.08. What is the ratio of the Net Disbursements (current US$) in 2007 in South Asia to that in World?
Offer a very short reply. 0.06. What is the ratio of the Net Disbursements (current US$) in 2008 in South Asia to that in World?
Ensure brevity in your answer.  0.01. What is the ratio of the Net Disbursements (current US$) in 2005 in Sub-Saharan Africa (all income levels) to that in Sub-Saharan Africa (developing only)?
Offer a terse response. 1. What is the ratio of the Net Disbursements (current US$) in 2007 in Sub-Saharan Africa (all income levels) to that in Sub-Saharan Africa (developing only)?
Ensure brevity in your answer.  1. What is the ratio of the Net Disbursements (current US$) of 2008 in Sub-Saharan Africa (all income levels) to that in Sub-Saharan Africa (developing only)?
Your answer should be very brief. 1. What is the ratio of the Net Disbursements (current US$) of 2005 in Sub-Saharan Africa (all income levels) to that in Upper middle income?
Offer a very short reply. 2.52. What is the ratio of the Net Disbursements (current US$) of 2006 in Sub-Saharan Africa (all income levels) to that in Upper middle income?
Offer a terse response. 10.39. What is the ratio of the Net Disbursements (current US$) of 2007 in Sub-Saharan Africa (all income levels) to that in Upper middle income?
Ensure brevity in your answer.  7.77. What is the ratio of the Net Disbursements (current US$) in 2008 in Sub-Saharan Africa (all income levels) to that in Upper middle income?
Keep it short and to the point. 4.06. What is the ratio of the Net Disbursements (current US$) of 2005 in Sub-Saharan Africa (all income levels) to that in World?
Offer a terse response. 0.58. What is the ratio of the Net Disbursements (current US$) in 2006 in Sub-Saharan Africa (all income levels) to that in World?
Make the answer very short. 0.74. What is the ratio of the Net Disbursements (current US$) of 2007 in Sub-Saharan Africa (all income levels) to that in World?
Provide a short and direct response. 0.78. What is the ratio of the Net Disbursements (current US$) of 2008 in Sub-Saharan Africa (all income levels) to that in World?
Offer a very short reply. 0.75. What is the ratio of the Net Disbursements (current US$) of 2005 in Sub-Saharan Africa (developing only) to that in Upper middle income?
Give a very brief answer. 2.52. What is the ratio of the Net Disbursements (current US$) of 2006 in Sub-Saharan Africa (developing only) to that in Upper middle income?
Ensure brevity in your answer.  10.39. What is the ratio of the Net Disbursements (current US$) in 2007 in Sub-Saharan Africa (developing only) to that in Upper middle income?
Offer a terse response. 7.77. What is the ratio of the Net Disbursements (current US$) of 2008 in Sub-Saharan Africa (developing only) to that in Upper middle income?
Give a very brief answer. 4.06. What is the ratio of the Net Disbursements (current US$) in 2005 in Sub-Saharan Africa (developing only) to that in World?
Your answer should be very brief. 0.58. What is the ratio of the Net Disbursements (current US$) in 2006 in Sub-Saharan Africa (developing only) to that in World?
Provide a short and direct response. 0.74. What is the ratio of the Net Disbursements (current US$) of 2007 in Sub-Saharan Africa (developing only) to that in World?
Your response must be concise. 0.78. What is the ratio of the Net Disbursements (current US$) in 2008 in Sub-Saharan Africa (developing only) to that in World?
Your response must be concise. 0.75. What is the ratio of the Net Disbursements (current US$) in 2005 in Upper middle income to that in World?
Ensure brevity in your answer.  0.23. What is the ratio of the Net Disbursements (current US$) in 2006 in Upper middle income to that in World?
Make the answer very short. 0.07. What is the ratio of the Net Disbursements (current US$) of 2007 in Upper middle income to that in World?
Your response must be concise. 0.1. What is the ratio of the Net Disbursements (current US$) in 2008 in Upper middle income to that in World?
Keep it short and to the point. 0.19. What is the difference between the highest and the second highest Net Disbursements (current US$) of 2005?
Give a very brief answer. 5.25e+06. What is the difference between the highest and the second highest Net Disbursements (current US$) in 2006?
Make the answer very short. 2.61e+06. What is the difference between the highest and the second highest Net Disbursements (current US$) of 2007?
Keep it short and to the point. 1.68e+06. What is the difference between the highest and the second highest Net Disbursements (current US$) of 2008?
Your response must be concise. 8.50e+06. What is the difference between the highest and the lowest Net Disbursements (current US$) in 2005?
Your answer should be very brief. 2.65e+07. What is the difference between the highest and the lowest Net Disbursements (current US$) of 2006?
Give a very brief answer. 1.95e+07. What is the difference between the highest and the lowest Net Disbursements (current US$) of 2007?
Give a very brief answer. 2.14e+07. What is the difference between the highest and the lowest Net Disbursements (current US$) of 2008?
Your answer should be very brief. 3.40e+07. 